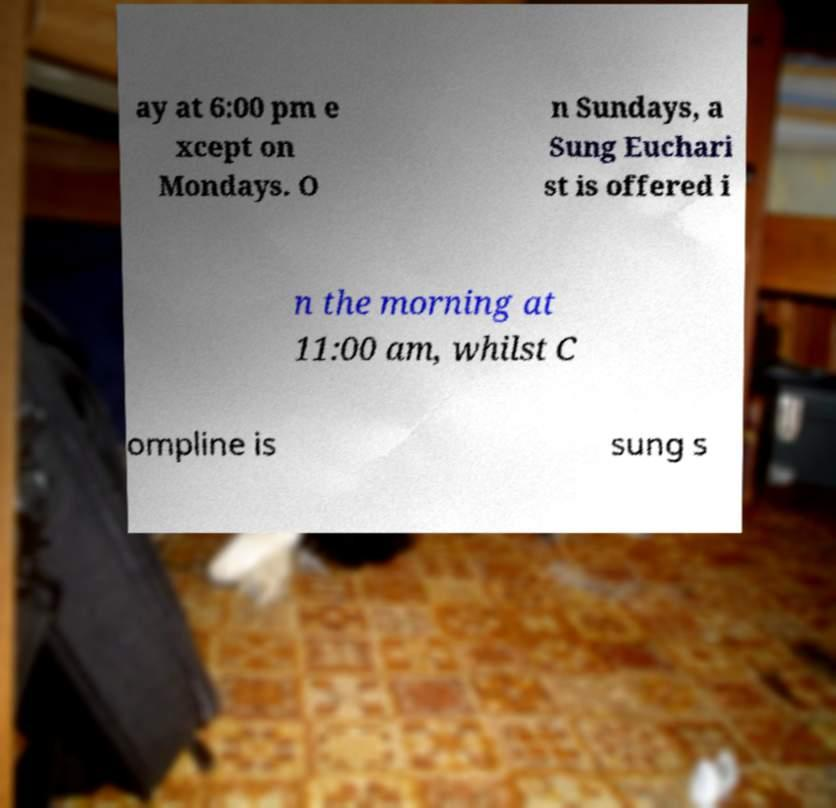Could you extract and type out the text from this image? ay at 6:00 pm e xcept on Mondays. O n Sundays, a Sung Euchari st is offered i n the morning at 11:00 am, whilst C ompline is sung s 